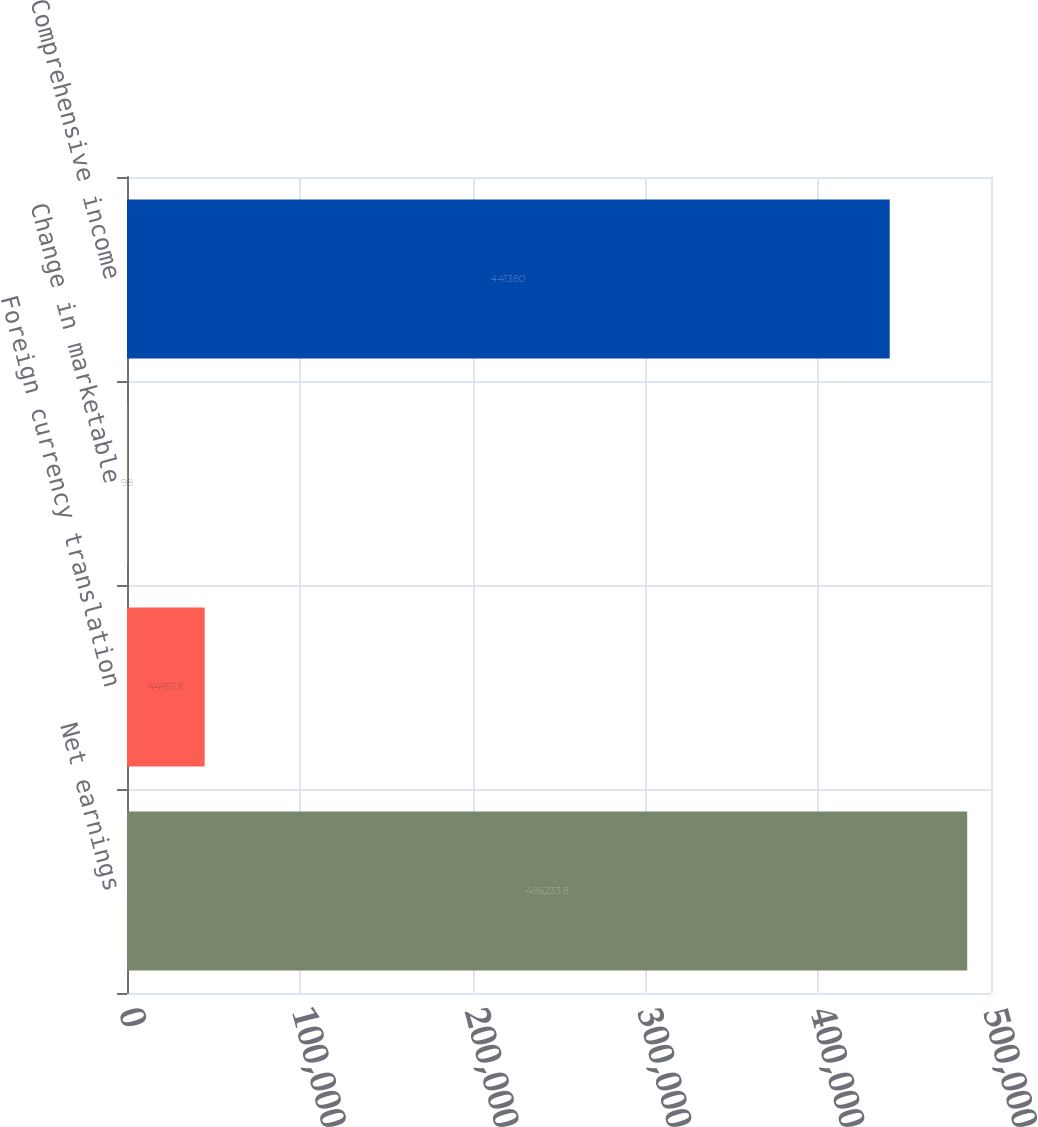Convert chart to OTSL. <chart><loc_0><loc_0><loc_500><loc_500><bar_chart><fcel>Net earnings<fcel>Foreign currency translation<fcel>Change in marketable<fcel>Comprehensive income<nl><fcel>486234<fcel>44951.8<fcel>98<fcel>441380<nl></chart> 